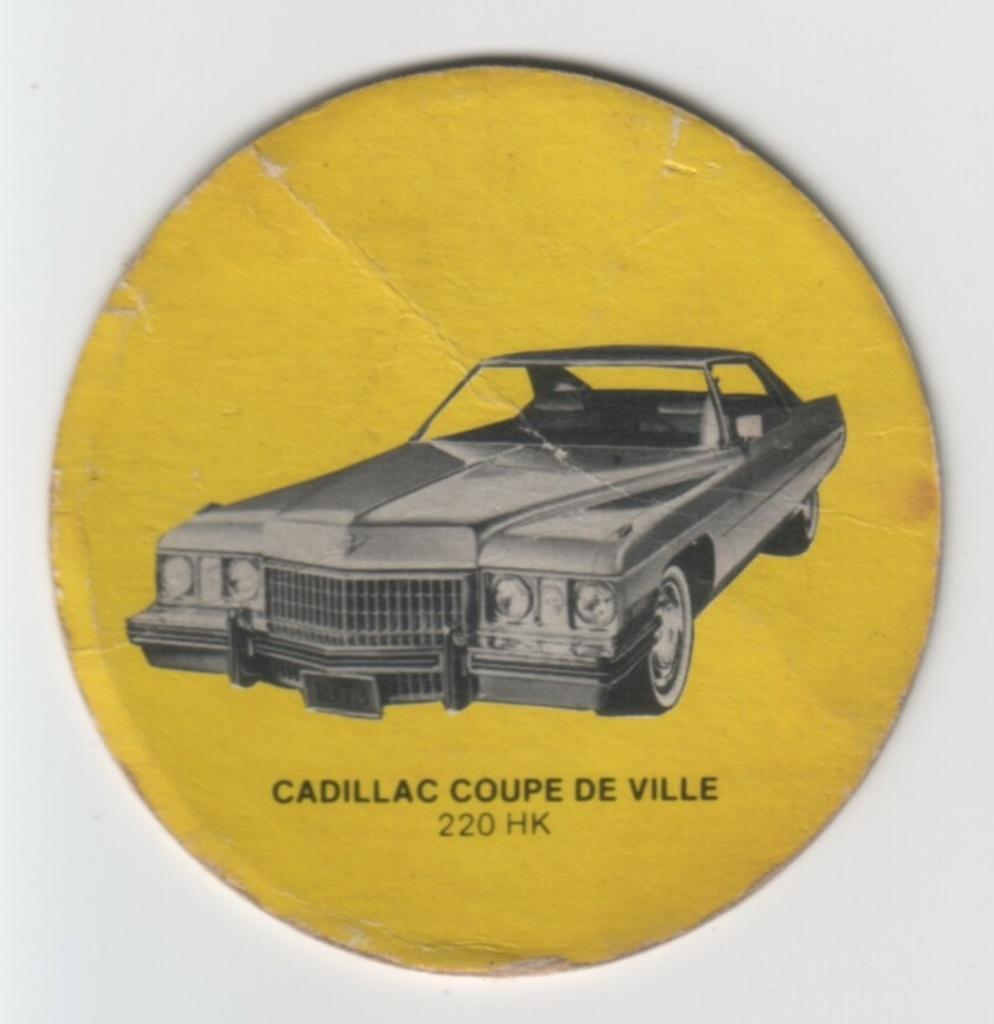What is the main object in the image? There is a yellow circular board in the image. What is on the board? There is a car on the board. Are there any words or letters on the board? Yes, there is text on the board. What can be seen in the background of the image? There is a wall in the background of the image. How many bears are visible on the circular board? There are no bears present on the circular board in the image. 